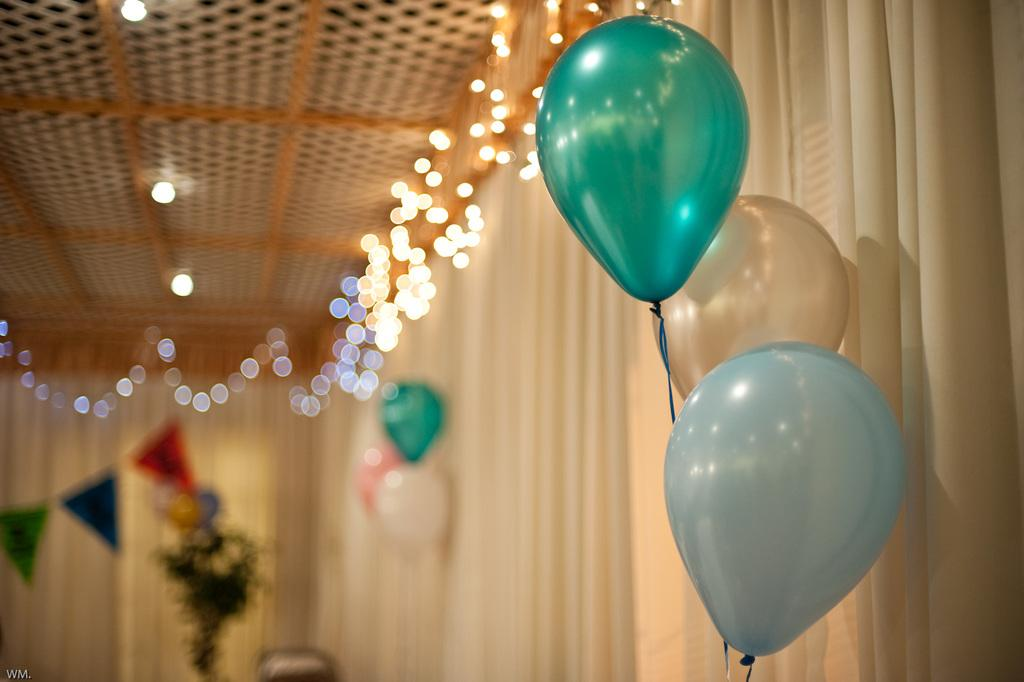What can be seen floating in the image? There are balloons in the image. Where are lights attached in the image? Lights are attached to the curtain and the ceiling in the image. What can be seen in the background of the image, although it appears blurry? There are flags in the background of the image. What type of popcorn is being served at the yak's birthday party in the image? There is no popcorn or yak present in the image. 